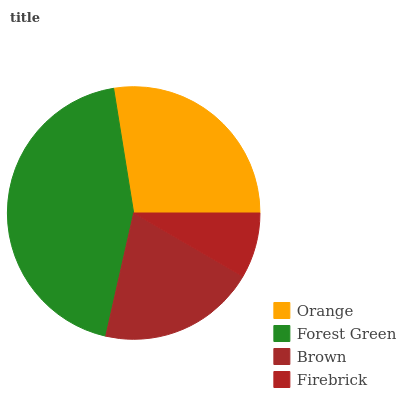Is Firebrick the minimum?
Answer yes or no. Yes. Is Forest Green the maximum?
Answer yes or no. Yes. Is Brown the minimum?
Answer yes or no. No. Is Brown the maximum?
Answer yes or no. No. Is Forest Green greater than Brown?
Answer yes or no. Yes. Is Brown less than Forest Green?
Answer yes or no. Yes. Is Brown greater than Forest Green?
Answer yes or no. No. Is Forest Green less than Brown?
Answer yes or no. No. Is Orange the high median?
Answer yes or no. Yes. Is Brown the low median?
Answer yes or no. Yes. Is Forest Green the high median?
Answer yes or no. No. Is Orange the low median?
Answer yes or no. No. 